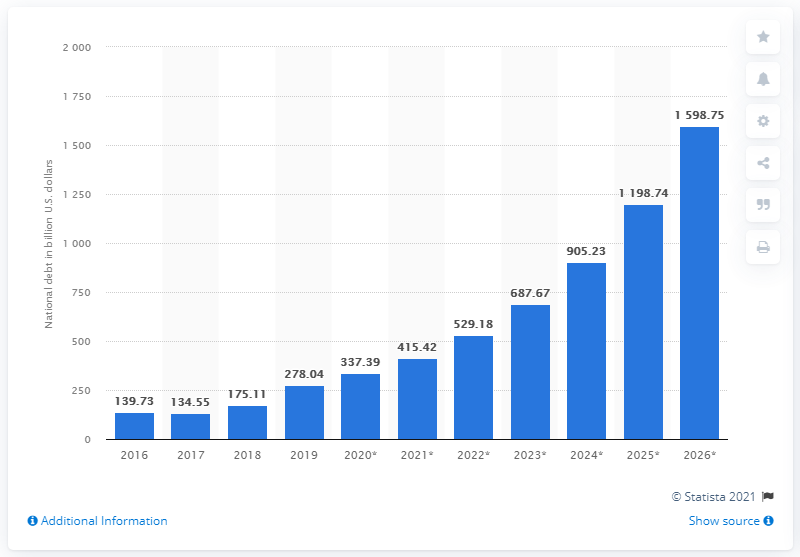Identify some key points in this picture. In 2019, Iran's national debt in dollars was approximately 278.04. 